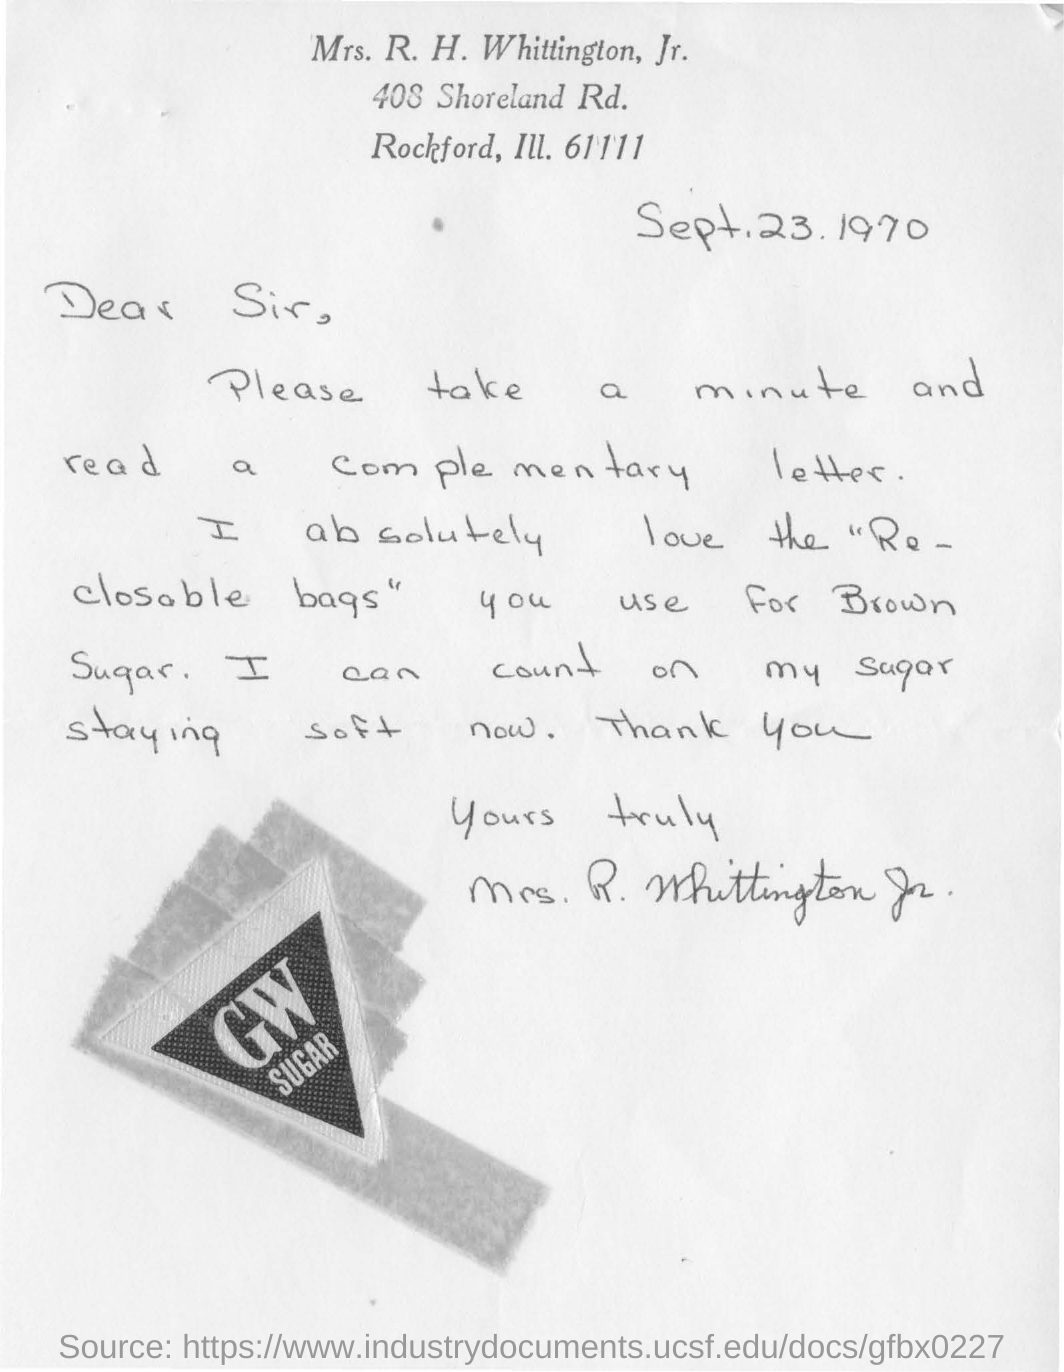Mention a couple of crucial points in this snapshot. The letter mentions brown sugar as the type of sugar. The letter was written by Mrs. R. H. Whittington, Jr. The date mentioned in this letter is September 23, 1970. 